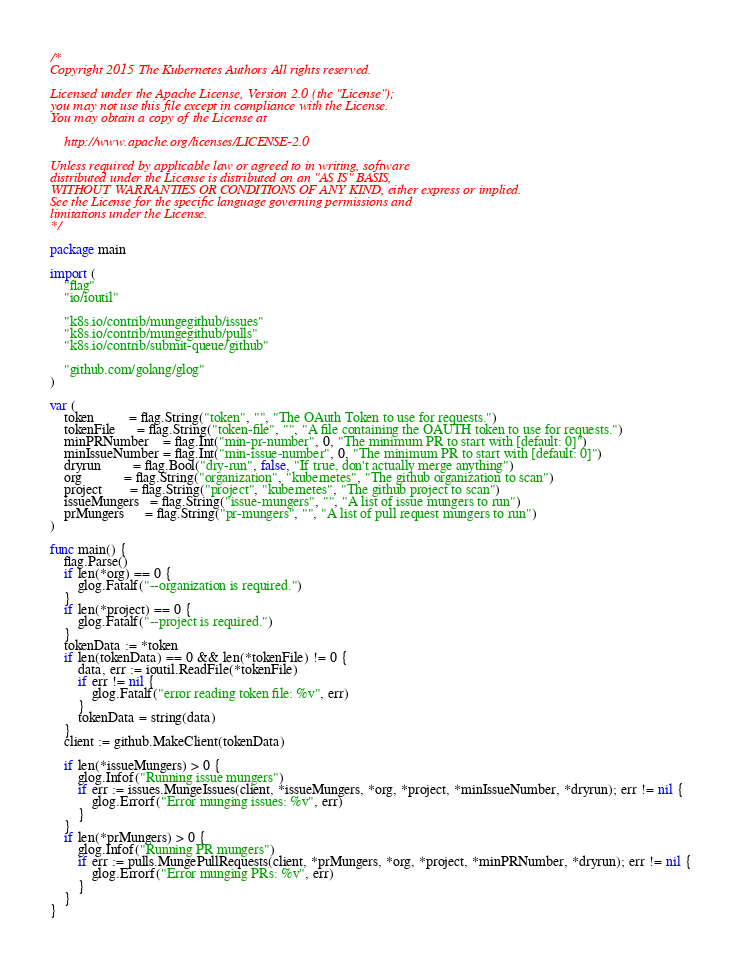Convert code to text. <code><loc_0><loc_0><loc_500><loc_500><_Go_>/*
Copyright 2015 The Kubernetes Authors All rights reserved.

Licensed under the Apache License, Version 2.0 (the "License");
you may not use this file except in compliance with the License.
You may obtain a copy of the License at

    http://www.apache.org/licenses/LICENSE-2.0

Unless required by applicable law or agreed to in writing, software
distributed under the License is distributed on an "AS IS" BASIS,
WITHOUT WARRANTIES OR CONDITIONS OF ANY KIND, either express or implied.
See the License for the specific language governing permissions and
limitations under the License.
*/

package main

import (
	"flag"
	"io/ioutil"

	"k8s.io/contrib/mungegithub/issues"
	"k8s.io/contrib/mungegithub/pulls"
	"k8s.io/contrib/submit-queue/github"

	"github.com/golang/glog"
)

var (
	token          = flag.String("token", "", "The OAuth Token to use for requests.")
	tokenFile      = flag.String("token-file", "", "A file containing the OAUTH token to use for requests.")
	minPRNumber    = flag.Int("min-pr-number", 0, "The minimum PR to start with [default: 0]")
	minIssueNumber = flag.Int("min-issue-number", 0, "The minimum PR to start with [default: 0]")
	dryrun         = flag.Bool("dry-run", false, "If true, don't actually merge anything")
	org            = flag.String("organization", "kubernetes", "The github organization to scan")
	project        = flag.String("project", "kubernetes", "The github project to scan")
	issueMungers   = flag.String("issue-mungers", "", "A list of issue mungers to run")
	prMungers      = flag.String("pr-mungers", "", "A list of pull request mungers to run")
)

func main() {
	flag.Parse()
	if len(*org) == 0 {
		glog.Fatalf("--organization is required.")
	}
	if len(*project) == 0 {
		glog.Fatalf("--project is required.")
	}
	tokenData := *token
	if len(tokenData) == 0 && len(*tokenFile) != 0 {
		data, err := ioutil.ReadFile(*tokenFile)
		if err != nil {
			glog.Fatalf("error reading token file: %v", err)
		}
		tokenData = string(data)
	}
	client := github.MakeClient(tokenData)

	if len(*issueMungers) > 0 {
		glog.Infof("Running issue mungers")
		if err := issues.MungeIssues(client, *issueMungers, *org, *project, *minIssueNumber, *dryrun); err != nil {
			glog.Errorf("Error munging issues: %v", err)
		}
	}
	if len(*prMungers) > 0 {
		glog.Infof("Running PR mungers")
		if err := pulls.MungePullRequests(client, *prMungers, *org, *project, *minPRNumber, *dryrun); err != nil {
			glog.Errorf("Error munging PRs: %v", err)
		}
	}
}
</code> 